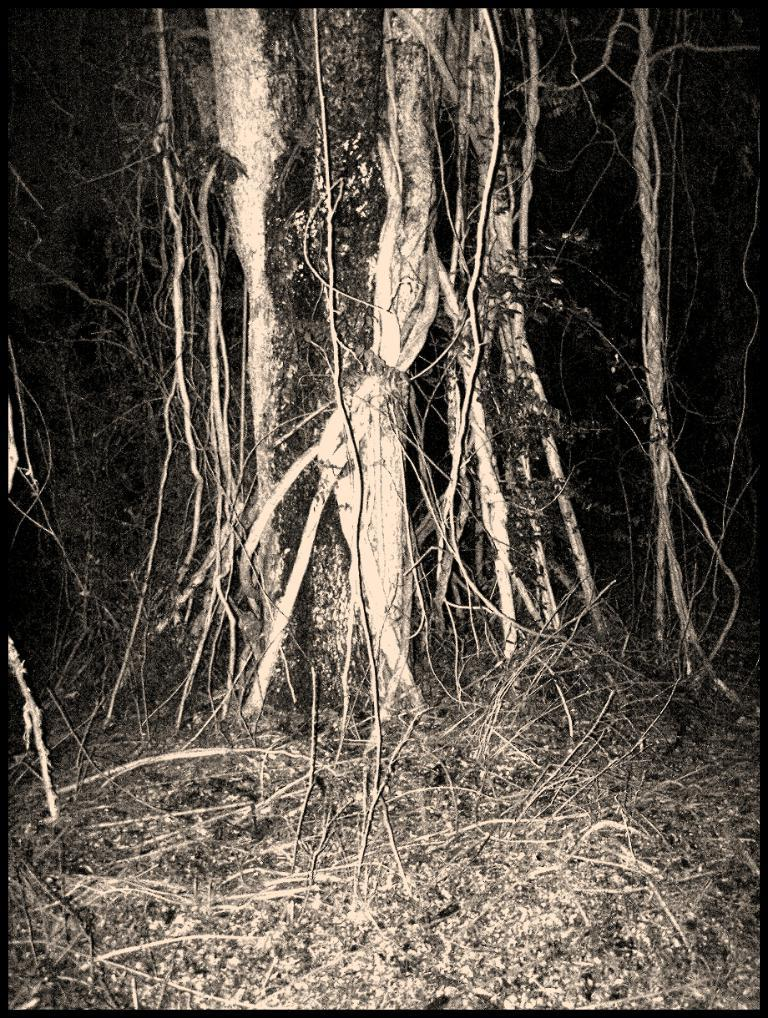What time of day is the image taken? The image is taken during night time. What type of plant can be seen in the image? There is a tree in the image. What are the small branches at the bottom of the image? There are twigs at the bottom of the image. How would you describe the overall lighting in the image? The background of the image is dark. What type of cushion is being used to support the tree in the image? There is no cushion present in the image, and the tree is not being supported by any object. 